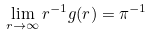<formula> <loc_0><loc_0><loc_500><loc_500>\lim _ { r \to \infty } r ^ { - 1 } g ( r ) = \pi ^ { - 1 }</formula> 